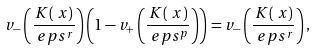<formula> <loc_0><loc_0><loc_500><loc_500>& v _ { - } \left ( \frac { K ( \ x ) } { \ e p s ^ { r } } \right ) \left ( 1 - v _ { + } \left ( \frac { K ( \ x ) } { \ e p s ^ { p } } \right ) \right ) = v _ { - } \left ( \frac { K ( \ x ) } { \ e p s ^ { r } } \right ) ,</formula> 